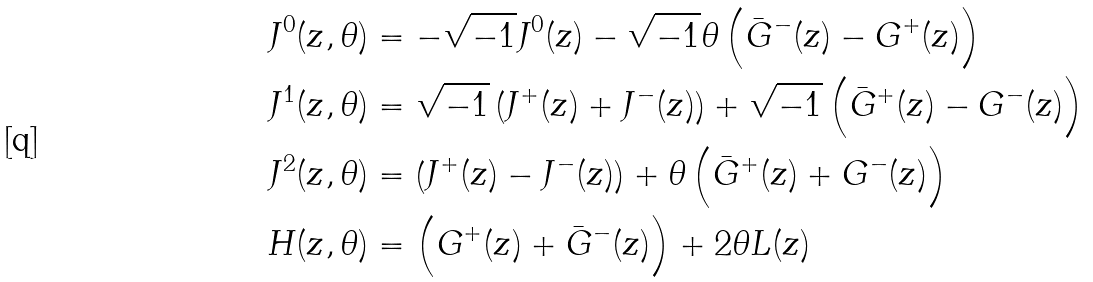Convert formula to latex. <formula><loc_0><loc_0><loc_500><loc_500>J ^ { 0 } ( z , \theta ) & = - \sqrt { - 1 } J ^ { 0 } ( z ) - \sqrt { - 1 } \theta \left ( \bar { G } ^ { - } ( z ) - G ^ { + } ( z ) \right ) \\ J ^ { 1 } ( z , \theta ) & = \sqrt { - 1 } \left ( J ^ { + } ( z ) + J ^ { - } ( z ) \right ) + \sqrt { - 1 } \left ( \bar { G } ^ { + } ( z ) - G ^ { - } ( z ) \right ) \\ J ^ { 2 } ( z , \theta ) & = \left ( J ^ { + } ( z ) - J ^ { - } ( z ) \right ) + \theta \left ( \bar { G } ^ { + } ( z ) + G ^ { - } ( z ) \right ) \\ H ( z , \theta ) & = \left ( G ^ { + } ( z ) + \bar { G } ^ { - } ( z ) \right ) + 2 \theta L ( z )</formula> 